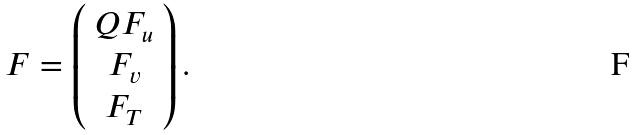<formula> <loc_0><loc_0><loc_500><loc_500>F = \left ( \begin{array} { c } Q F _ { u } \\ F _ { v } \\ F _ { T } \end{array} \right ) .</formula> 